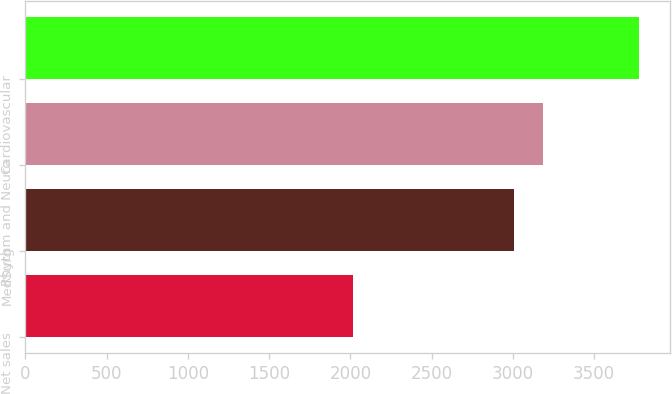Convert chart to OTSL. <chart><loc_0><loc_0><loc_500><loc_500><bar_chart><fcel>Net sales<fcel>MedSurg<fcel>Rhythm and Neuro<fcel>Cardiovascular<nl><fcel>2018<fcel>3007<fcel>3182.9<fcel>3777<nl></chart> 